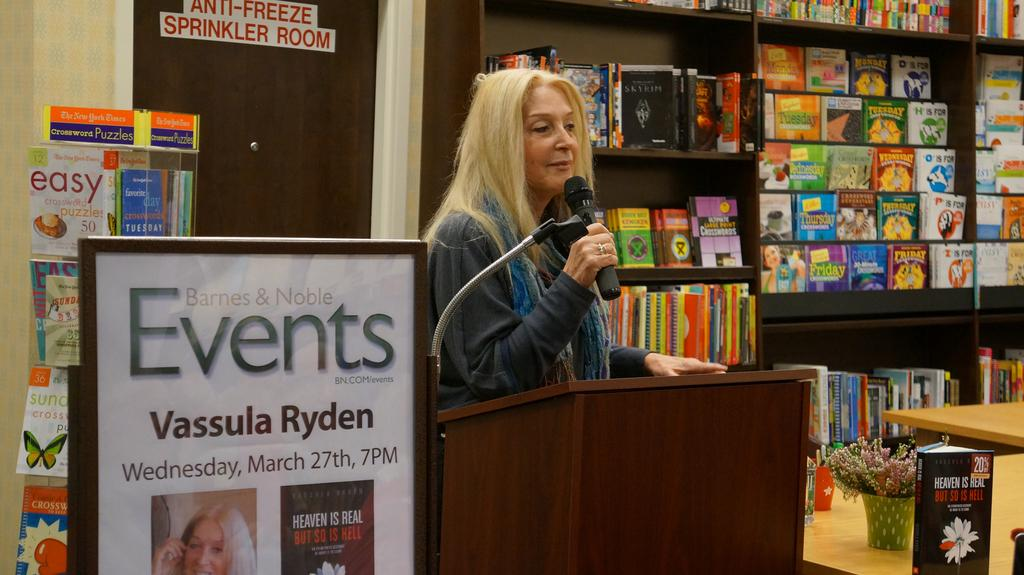<image>
Share a concise interpretation of the image provided. Lady standing beside poster that says Vassula Ryden. 